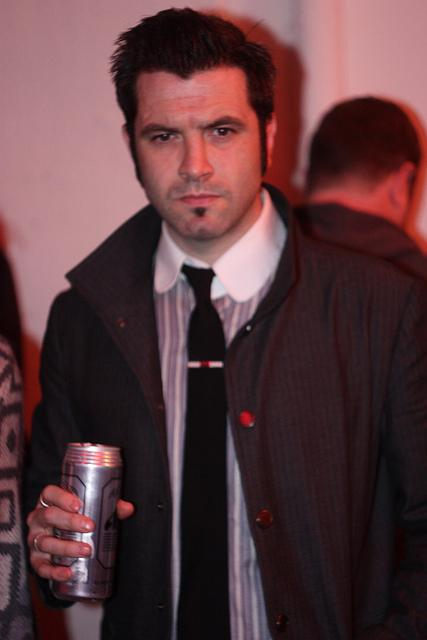How is the man holding the can feeling?

Choices:
A) friendly
B) happy
C) amused
D) angry angry 